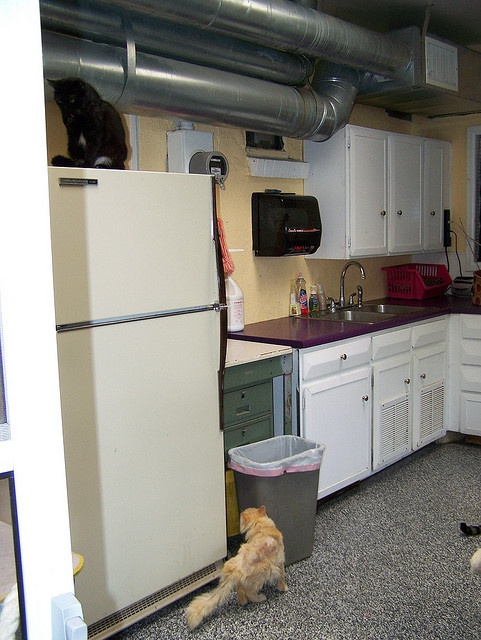Describe the objects in this image and their specific colors. I can see refrigerator in white, darkgray, lightgray, and gray tones, cat in white, black, and gray tones, cat in white, tan, and gray tones, and sink in white, black, and gray tones in this image. 